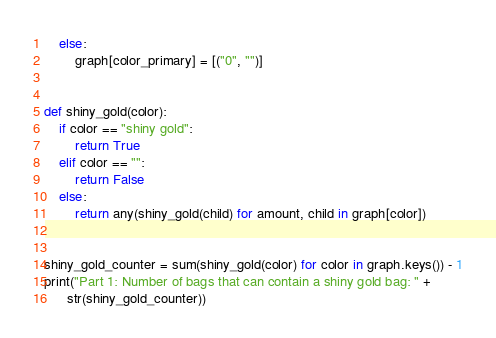<code> <loc_0><loc_0><loc_500><loc_500><_Python_>    else:
        graph[color_primary] = [("0", "")]


def shiny_gold(color):
    if color == "shiny gold":
        return True
    elif color == "":
        return False
    else:
        return any(shiny_gold(child) for amount, child in graph[color])


shiny_gold_counter = sum(shiny_gold(color) for color in graph.keys()) - 1
print("Part 1: Number of bags that can contain a shiny gold bag: " +
      str(shiny_gold_counter))
</code> 